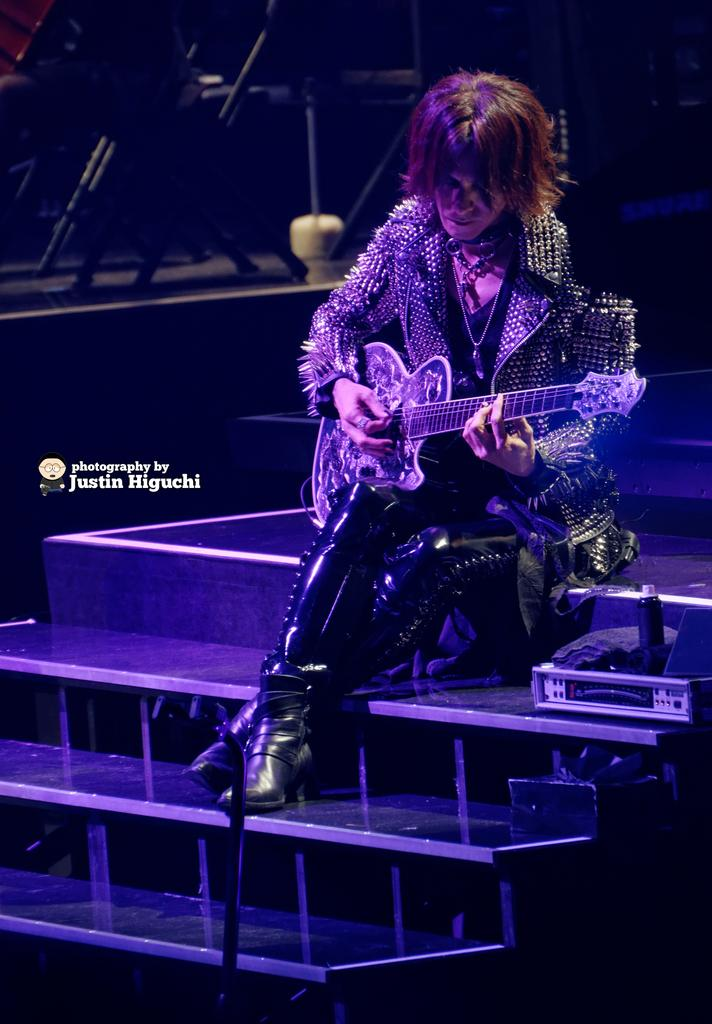Who is the main subject in the image? There is a woman in the image. What is the woman doing in the image? The woman is seated on the stairs and playing a guitar. What type of design can be seen on the woman's nails in the image? A: There is no information about the woman's nails or any design on them in the image. 